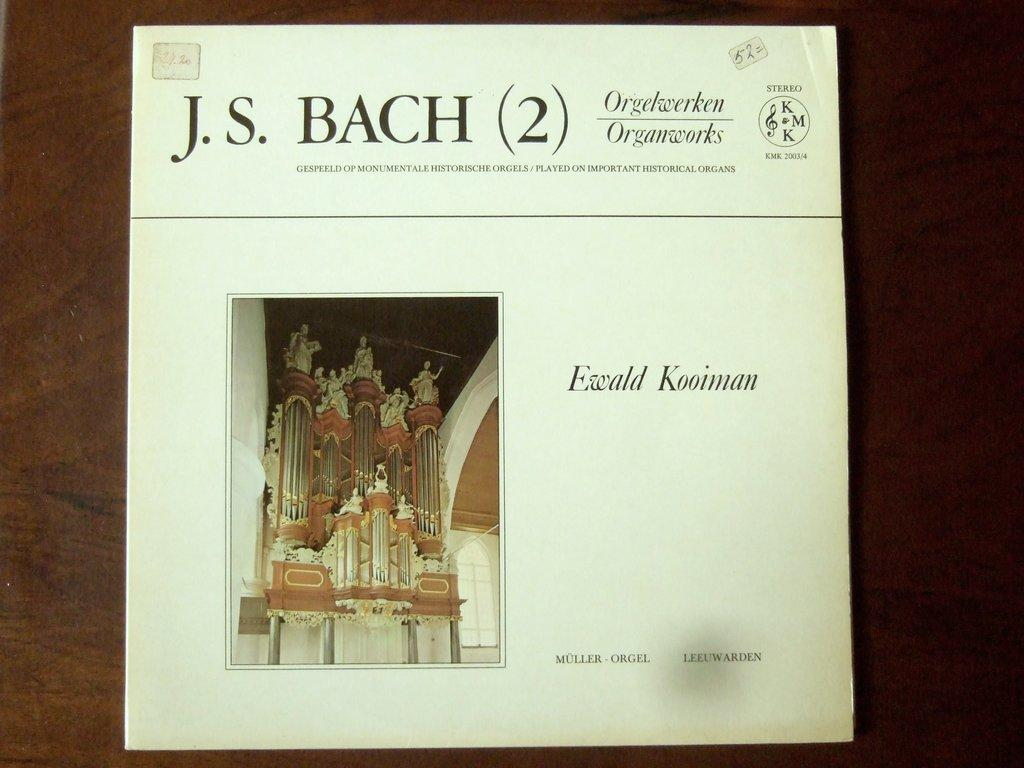<image>
Render a clear and concise summary of the photo. An album of the works of J.S Bach has an organ on the cover. 